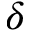Convert formula to latex. <formula><loc_0><loc_0><loc_500><loc_500>\delta</formula> 